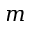<formula> <loc_0><loc_0><loc_500><loc_500>m</formula> 